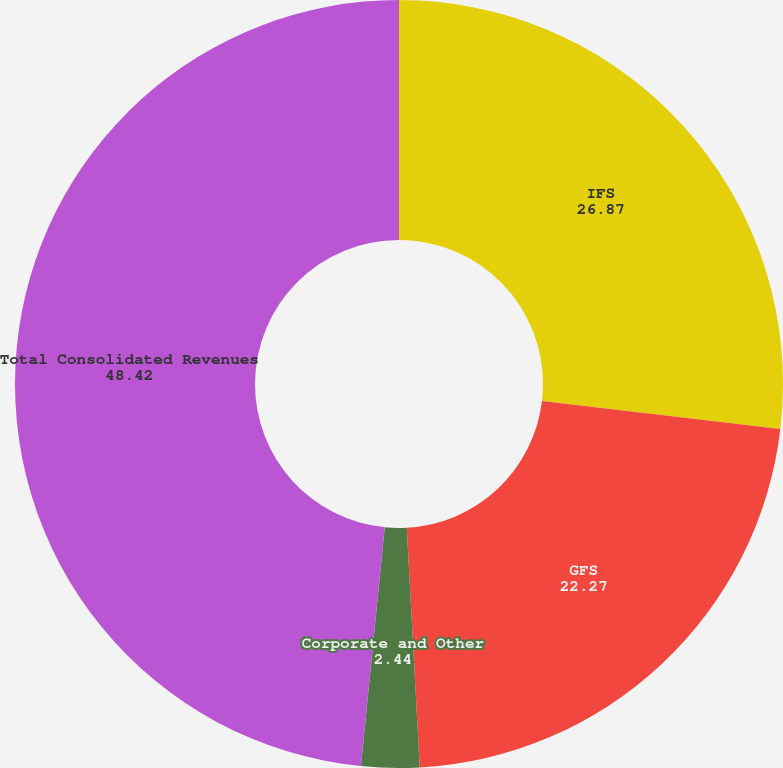Convert chart to OTSL. <chart><loc_0><loc_0><loc_500><loc_500><pie_chart><fcel>IFS<fcel>GFS<fcel>Corporate and Other<fcel>Total Consolidated Revenues<nl><fcel>26.87%<fcel>22.27%<fcel>2.44%<fcel>48.42%<nl></chart> 